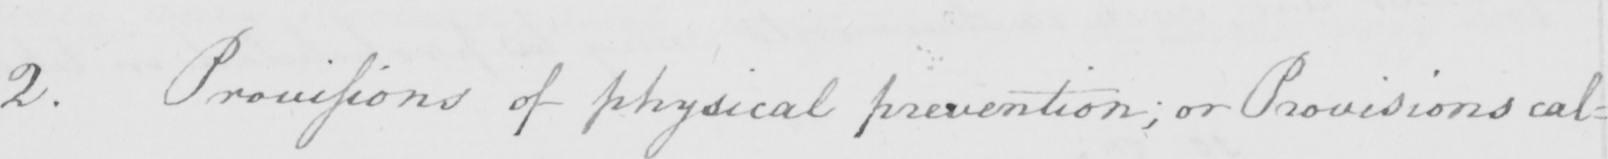What is written in this line of handwriting? 2 . Provisions of physical prevention ; or Provisions cal= 